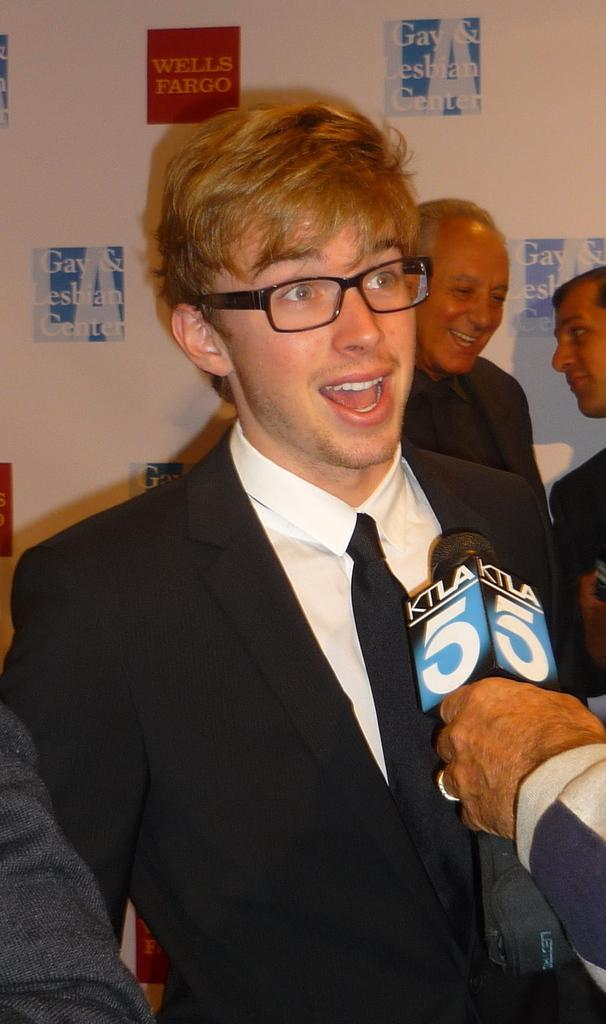How many people are in the image? There are people in the image, but the exact number is not specified. What is one person doing in the image? One person is holding a microphone. What can be seen in the background of the image? There is a board with text in the background of the image. What type of instrument is the person playing in the image? There is no instrument present in the image; only a microphone is visible. Can you tell me how many people are swimming in the image? There is no swimming activity depicted in the image. 